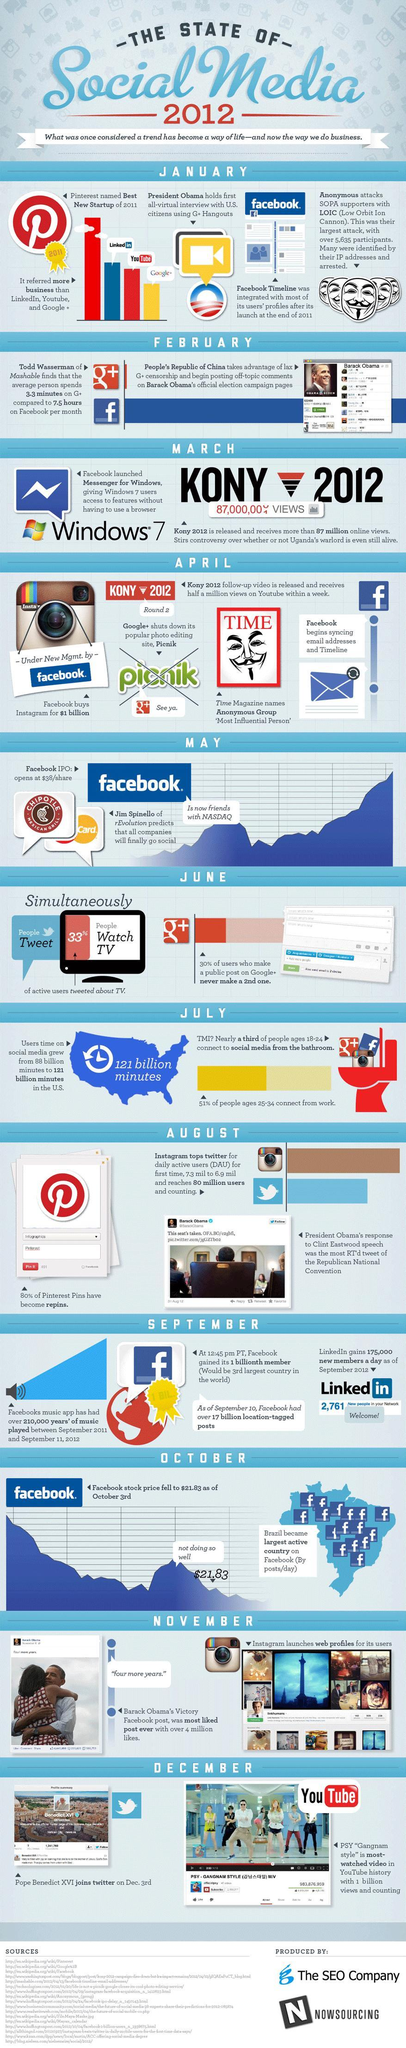Which is the third-best new startup of 2011?
Answer the question with a short phrase. Youtube What percentage of people are not watching the tv? 67% Which is the second best new startup of 2011? Linkedin 